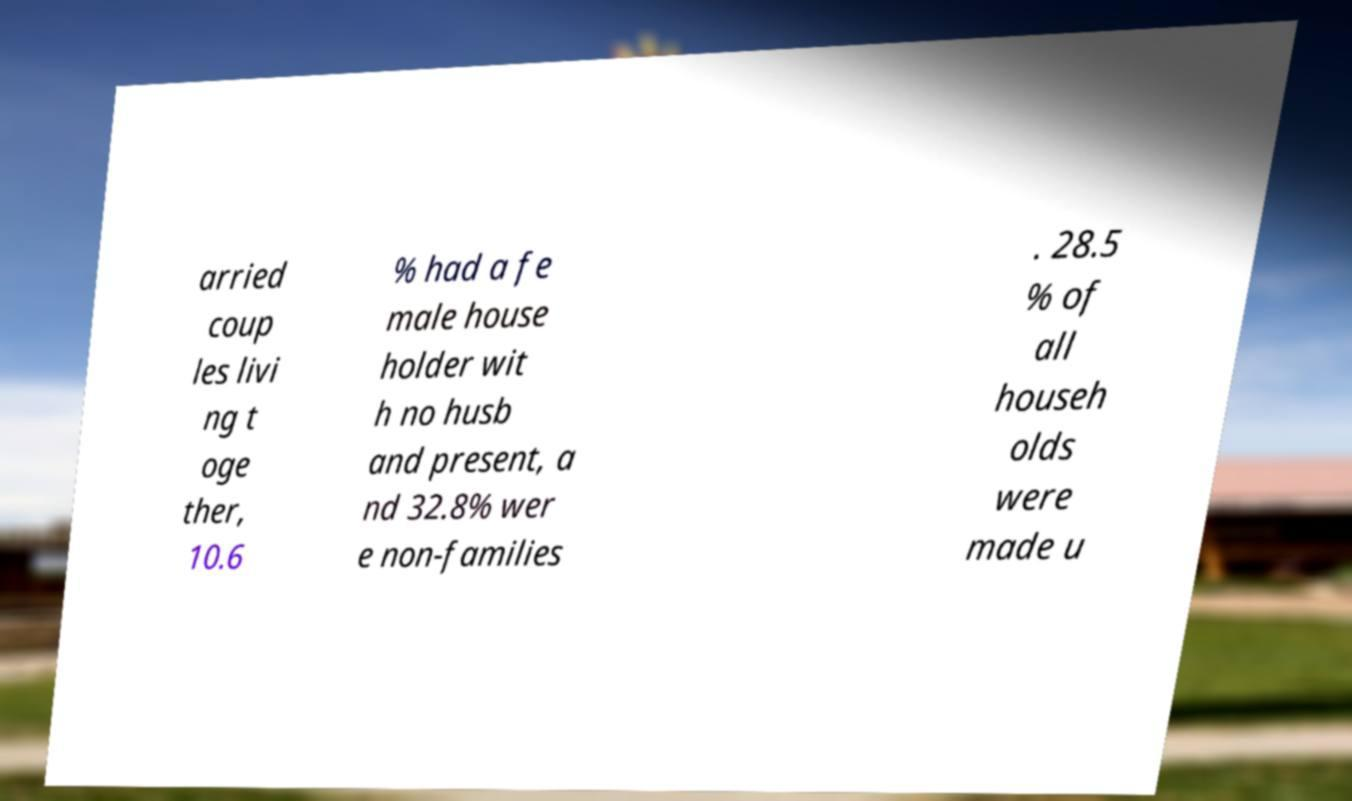Can you read and provide the text displayed in the image?This photo seems to have some interesting text. Can you extract and type it out for me? arried coup les livi ng t oge ther, 10.6 % had a fe male house holder wit h no husb and present, a nd 32.8% wer e non-families . 28.5 % of all househ olds were made u 